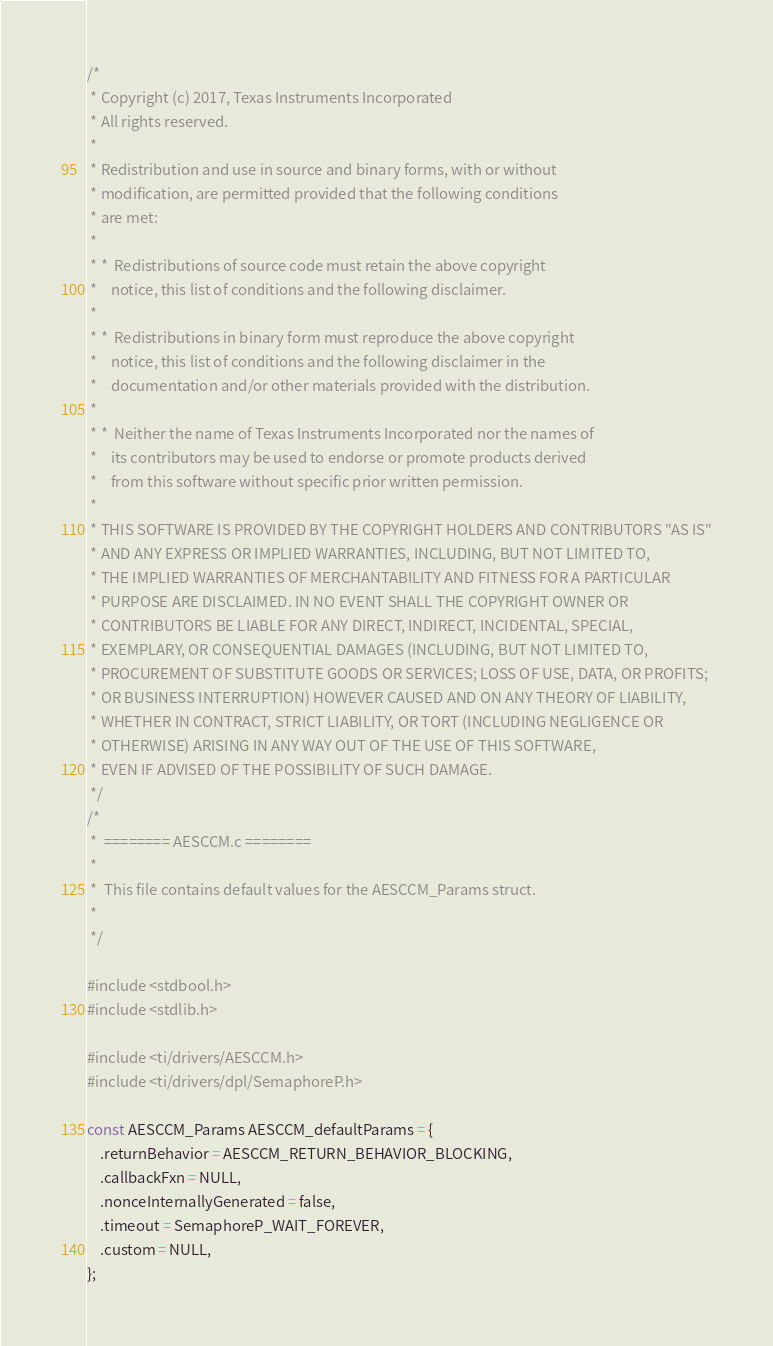<code> <loc_0><loc_0><loc_500><loc_500><_C_>/*
 * Copyright (c) 2017, Texas Instruments Incorporated
 * All rights reserved.
 *
 * Redistribution and use in source and binary forms, with or without
 * modification, are permitted provided that the following conditions
 * are met:
 *
 * *  Redistributions of source code must retain the above copyright
 *    notice, this list of conditions and the following disclaimer.
 *
 * *  Redistributions in binary form must reproduce the above copyright
 *    notice, this list of conditions and the following disclaimer in the
 *    documentation and/or other materials provided with the distribution.
 *
 * *  Neither the name of Texas Instruments Incorporated nor the names of
 *    its contributors may be used to endorse or promote products derived
 *    from this software without specific prior written permission.
 *
 * THIS SOFTWARE IS PROVIDED BY THE COPYRIGHT HOLDERS AND CONTRIBUTORS "AS IS"
 * AND ANY EXPRESS OR IMPLIED WARRANTIES, INCLUDING, BUT NOT LIMITED TO,
 * THE IMPLIED WARRANTIES OF MERCHANTABILITY AND FITNESS FOR A PARTICULAR
 * PURPOSE ARE DISCLAIMED. IN NO EVENT SHALL THE COPYRIGHT OWNER OR
 * CONTRIBUTORS BE LIABLE FOR ANY DIRECT, INDIRECT, INCIDENTAL, SPECIAL,
 * EXEMPLARY, OR CONSEQUENTIAL DAMAGES (INCLUDING, BUT NOT LIMITED TO,
 * PROCUREMENT OF SUBSTITUTE GOODS OR SERVICES; LOSS OF USE, DATA, OR PROFITS;
 * OR BUSINESS INTERRUPTION) HOWEVER CAUSED AND ON ANY THEORY OF LIABILITY,
 * WHETHER IN CONTRACT, STRICT LIABILITY, OR TORT (INCLUDING NEGLIGENCE OR
 * OTHERWISE) ARISING IN ANY WAY OUT OF THE USE OF THIS SOFTWARE,
 * EVEN IF ADVISED OF THE POSSIBILITY OF SUCH DAMAGE.
 */
/*
 *  ======== AESCCM.c ========
 *
 *  This file contains default values for the AESCCM_Params struct.
 *
 */

#include <stdbool.h>
#include <stdlib.h>

#include <ti/drivers/AESCCM.h>
#include <ti/drivers/dpl/SemaphoreP.h>

const AESCCM_Params AESCCM_defaultParams = {
    .returnBehavior = AESCCM_RETURN_BEHAVIOR_BLOCKING,
    .callbackFxn = NULL,
    .nonceInternallyGenerated = false,
    .timeout = SemaphoreP_WAIT_FOREVER,
    .custom = NULL,
};
</code> 